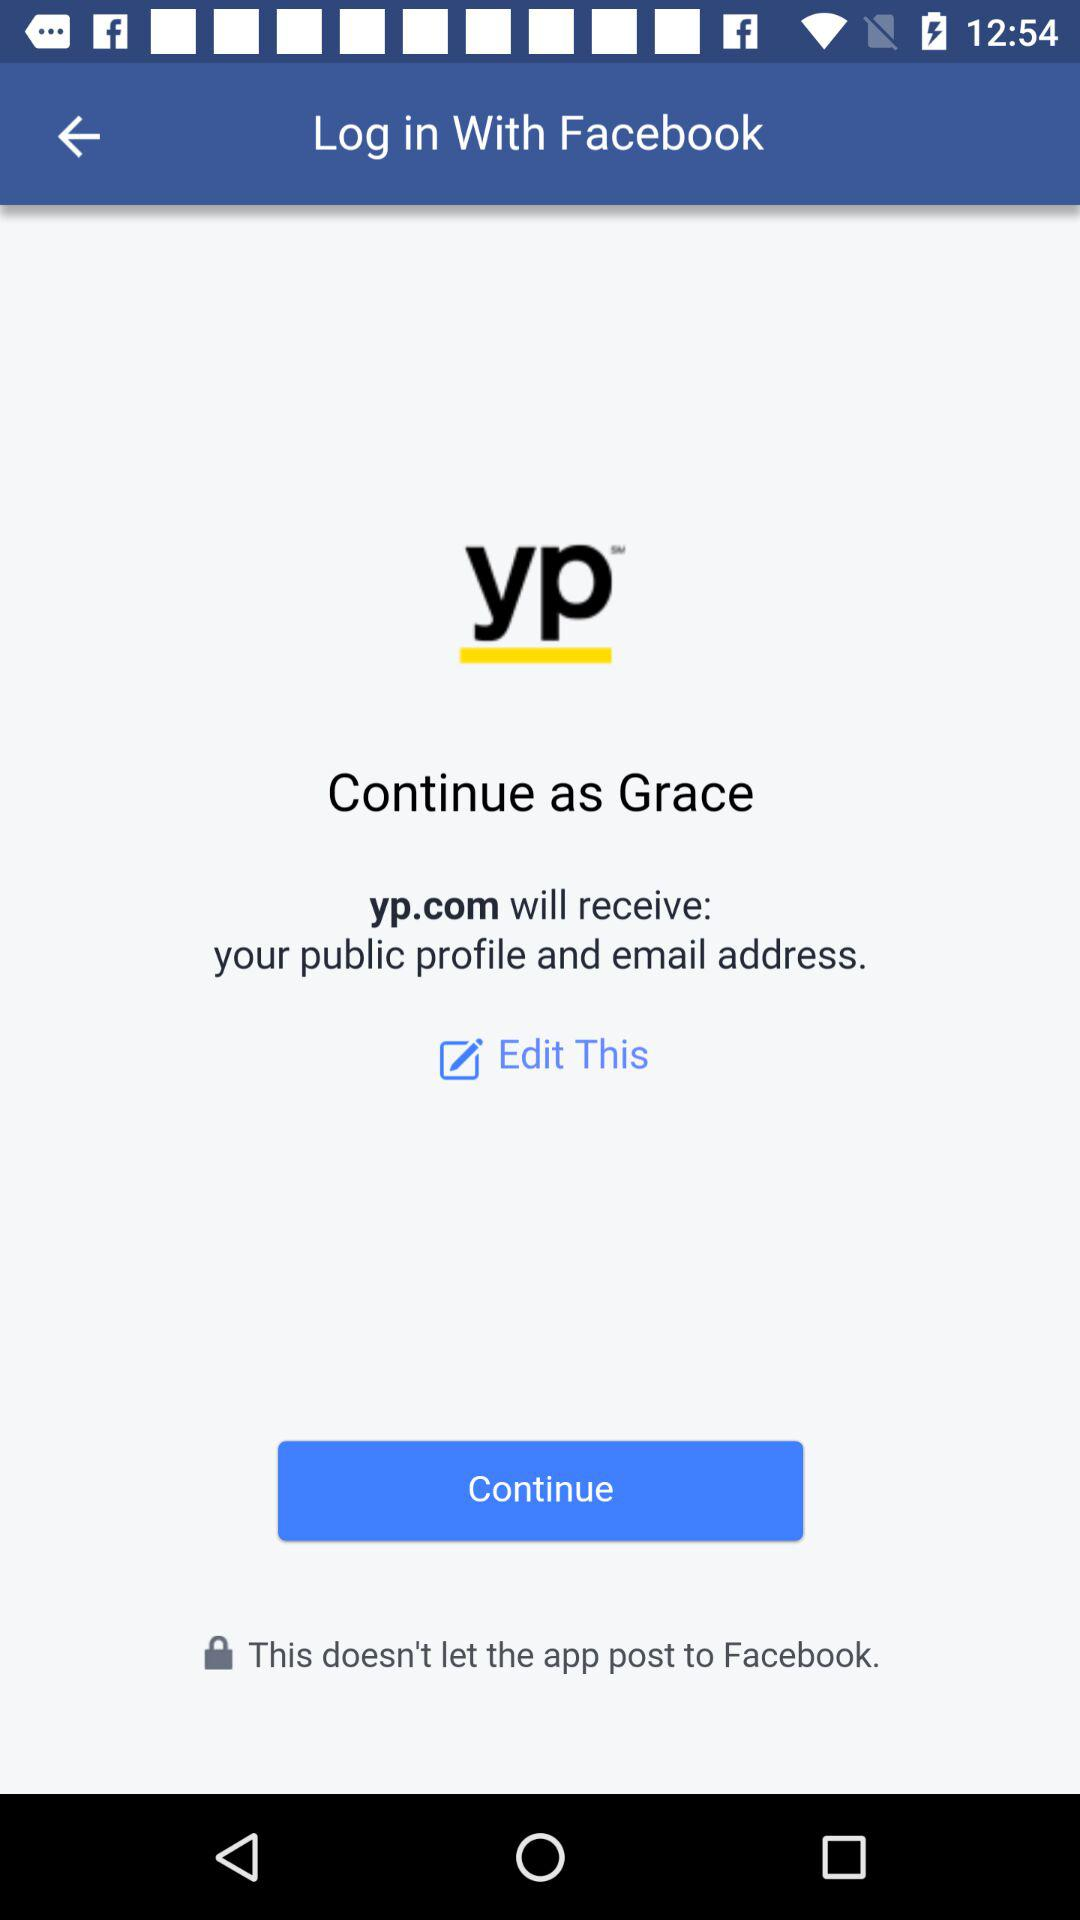Which information will "yp.com" receive? The application "yp.com" will receive the public profile and email address. 